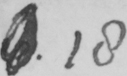Transcribe the text shown in this historical manuscript line. 6 18 